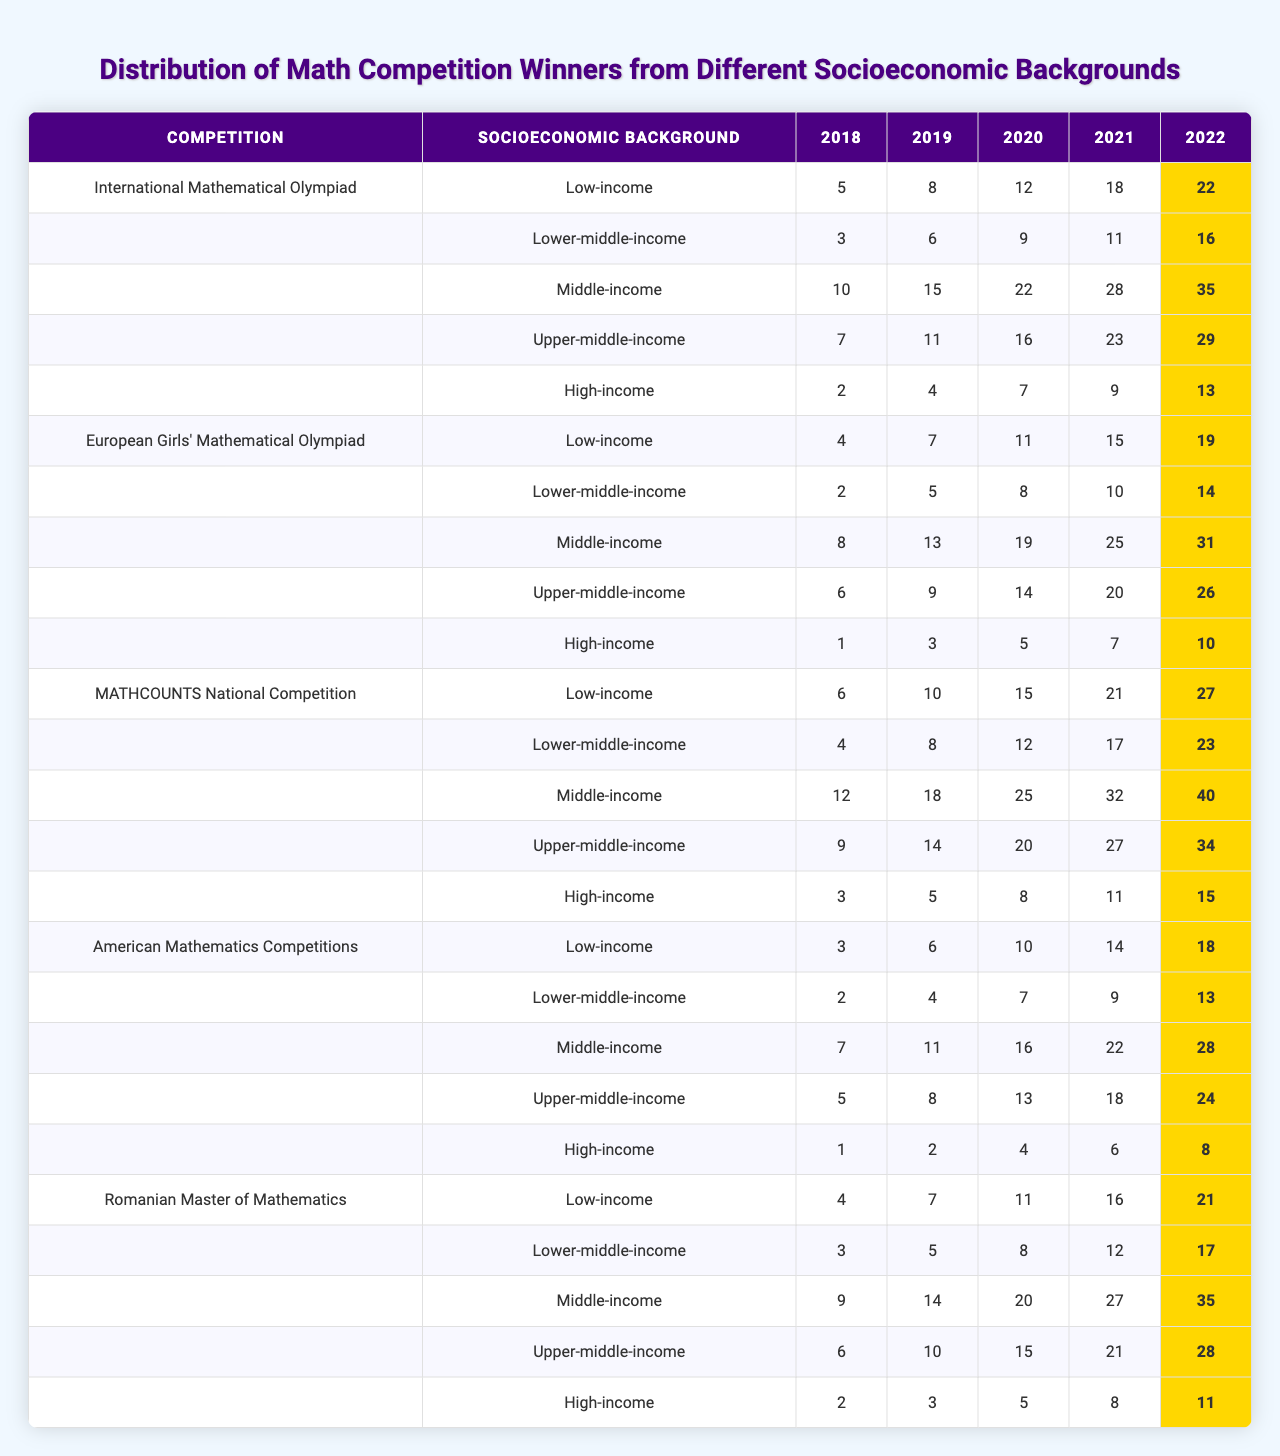What is the highest number of winners from the High-income background in 2022 for the International Mathematical Olympiad? Looking at the table under the International Mathematical Olympiad in the High-income category for the year 2022, the value is 13. This is the only value listed for this demographic for that competition in 2022.
Answer: 13 Which socioeconomic background had the most winners in 2021 for the American Mathematics Competitions? For the American Mathematics Competitions in 2021, the winners from Upper-middle-income background had the most with a total of 23, which is higher than the other backgrounds listed.
Answer: Upper-middle-income What is the total number of winners from the Low-income group across all competitions in 2019? The winners from the Low-income group in 2019 are: International Mathematical Olympiad (8), European Girls' Mathematical Olympiad (6), MATHCOUNTS National Competition (15), American Mathematics Competitions (11), and Romanian Master of Mathematics (4). Adding these together gives 8 + 6 + 15 + 11 + 4 = 44.
Answer: 44 Was the number of winners from the Middle-income category higher in 2018 compared to 2022 for the MATHCOUNTS National Competition? In 2018, the Middle-income category had 10 winners for MATHCOUNTS, while in 2022 they had 35 winners. Comparing these values shows that 35 is greater than 10, hence yes, the number of winners was higher in 2022.
Answer: Yes What is the average number of winners from the Lower-middle-income background in 2020 across all competitions? The values for Lower-middle-income in 2020 are: 12 (International Mathematical Olympiad), 9 (European Girls' Mathematical Olympiad), 22 (MATHCOUNTS), 16 (American Mathematics Competitions), and 7 (Romanian Master of Mathematics). Summing those gives 12 + 9 + 22 + 16 + 7 = 66, and since there are 5 competitions, the average is 66/5 = 13.2.
Answer: 13.2 Identify the competition in which Low-income winners decreased from 2018 to 2021. Looking at the years 2018 to 2021 for the Low-income group, the winners are: 5 (2018), 3 (2019), 10 (2020), and 7 (2021). The values for 2018 to 2021 show a decrease from 5 to 3 in 2019, thus the competition where Low-income winners decreased is the International Mathematical Olympiad.
Answer: International Mathematical Olympiad Which socioeconomic background had the least number of winners in the Romanian Master of Mathematics for 2020? For the Romanian Master of Mathematics in 2020, the figures are: Low-income (7), Lower-middle-income (11), Middle-income (25), Upper-middle-income (20), and High-income (8). The Low-income category had the least with 7.
Answer: Low-income Calculate the percentage increase in winners from the Upper-middle-income background in the American Mathematics Competitions between 2018 and 2022. The number of winners for Upper-middle-income in 2018 is 16 and in 2022 is 29. The increase is 29 - 16 = 13. To find the percentage increase: (13/16) * 100 = 81.25%.
Answer: 81.25% In which year did the Romanian Master of Mathematics show its highest number of winners from the Middle-income background? Checking the Middle-income winners for the Romanian Master of Mathematics, the values are: 12 (2018), 18 (2019), 25 (2020), 32 (2021), and 40 (2022). The highest number is in 2022 with 40 winners.
Answer: 2022 What percentage of the total MATHCOUNTS winners came from the Low-income background in 2019? For MATHCOUNTS in 2019, the Low-income winners are 15, and the total winners across all backgrounds for that year is 15 + 22 + 28 + 16 + 11 = 92. The percentage is (15/92) * 100 ≈ 16.3%.
Answer: 16.3% Which competition had the highest number of winners from the High-income background in 2021? In 2021, the High-income winners are: International Mathematical Olympiad (22), European Girls' Mathematical Olympiad (16), MATHCOUNTS (35), American Mathematics Competitions (29), and Romanian Master of Mathematics (13). The highest is 35 from MATHCOUNTS.
Answer: MATHCOUNTS 